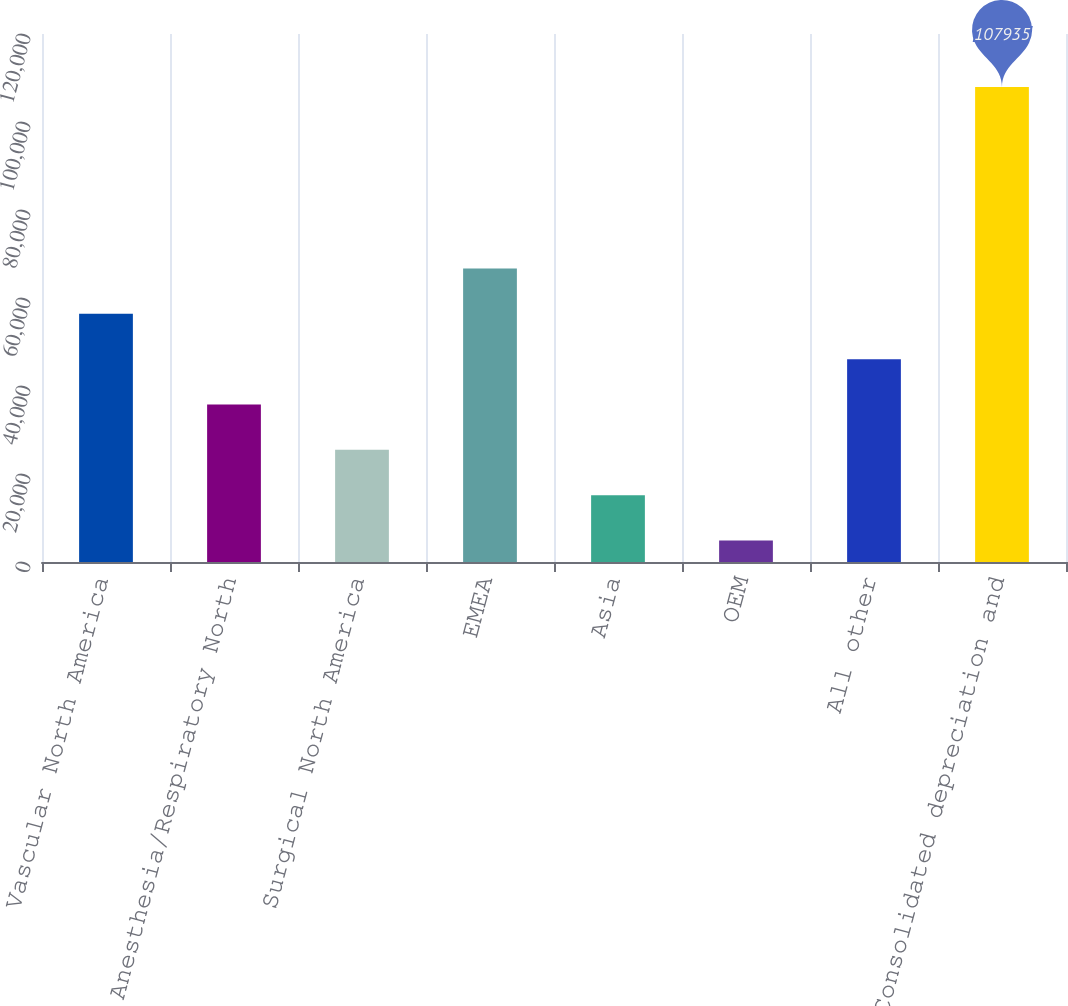<chart> <loc_0><loc_0><loc_500><loc_500><bar_chart><fcel>Vascular North America<fcel>Anesthesia/Respiratory North<fcel>Surgical North America<fcel>EMEA<fcel>Asia<fcel>OEM<fcel>All other<fcel>Consolidated depreciation and<nl><fcel>56405.5<fcel>35793.7<fcel>25487.8<fcel>66711.4<fcel>15181.9<fcel>4876<fcel>46099.6<fcel>107935<nl></chart> 